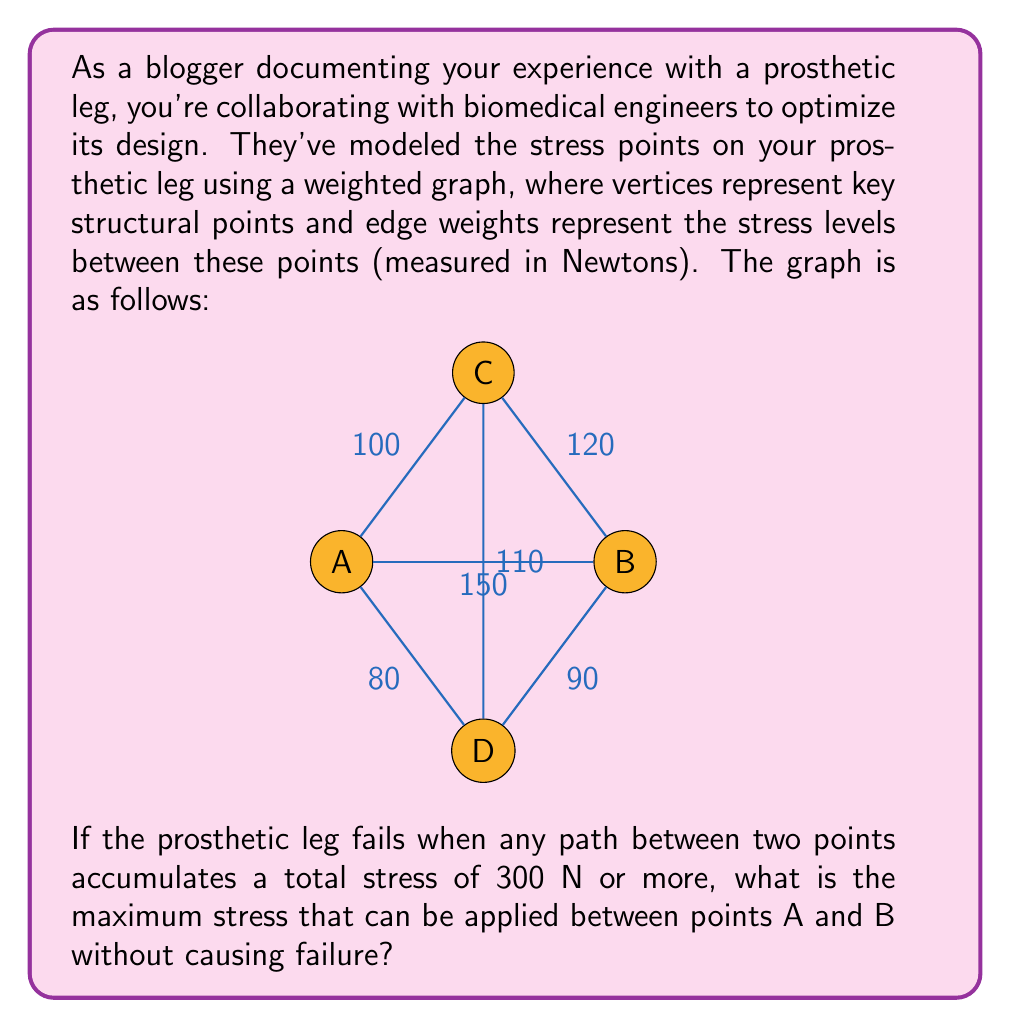Can you answer this question? To solve this problem, we need to find the maximum stress that can be applied between points A and B without creating any path with a total stress of 300 N or more. We'll use Dijkstra's algorithm to find the shortest (least stressful) path between A and B, then calculate how much additional stress can be added to the A-B edge.

1) First, let's find the shortest path from A to B without using the direct A-B edge:

   A -> C -> B: 100 + 120 = 220 N
   A -> D -> B: 80 + 90 = 170 N

   The shortest path is A -> D -> B with 170 N.

2) Now, we need to find how much stress we can add to the A-B edge without causing any path to reach 300 N:

   - For the path A -> B: 
     $300 - 150 = 150$ N can be added

   - For the path A -> D -> B: 
     $300 - 170 = 130$ N can be added

   - For the path A -> C -> B:
     $300 - 220 = 80$ N can be added

3) The maximum stress we can add is the minimum of these values: 80 N.

4) Therefore, the maximum total stress between A and B is:
   $150 + 80 = 230$ N

This ensures that no path in the graph exceeds 300 N of total stress.
Answer: The maximum stress that can be applied between points A and B without causing failure is 230 N. 